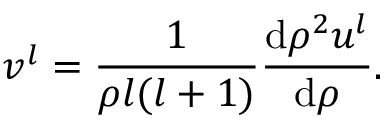Convert formula to latex. <formula><loc_0><loc_0><loc_500><loc_500>v ^ { l } = \frac { 1 } { \rho l ( l + 1 ) } \frac { d \rho ^ { 2 } u ^ { l } } { d \rho } .</formula> 